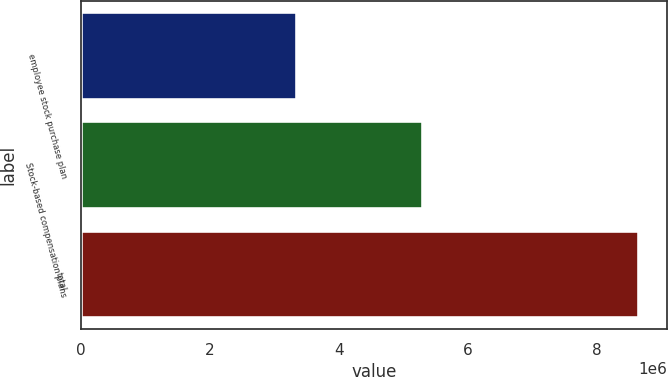<chart> <loc_0><loc_0><loc_500><loc_500><bar_chart><fcel>employee stock purchase plan<fcel>Stock-based compensation plans<fcel>total<nl><fcel>3.34774e+06<fcel>5.31288e+06<fcel>8.66062e+06<nl></chart> 